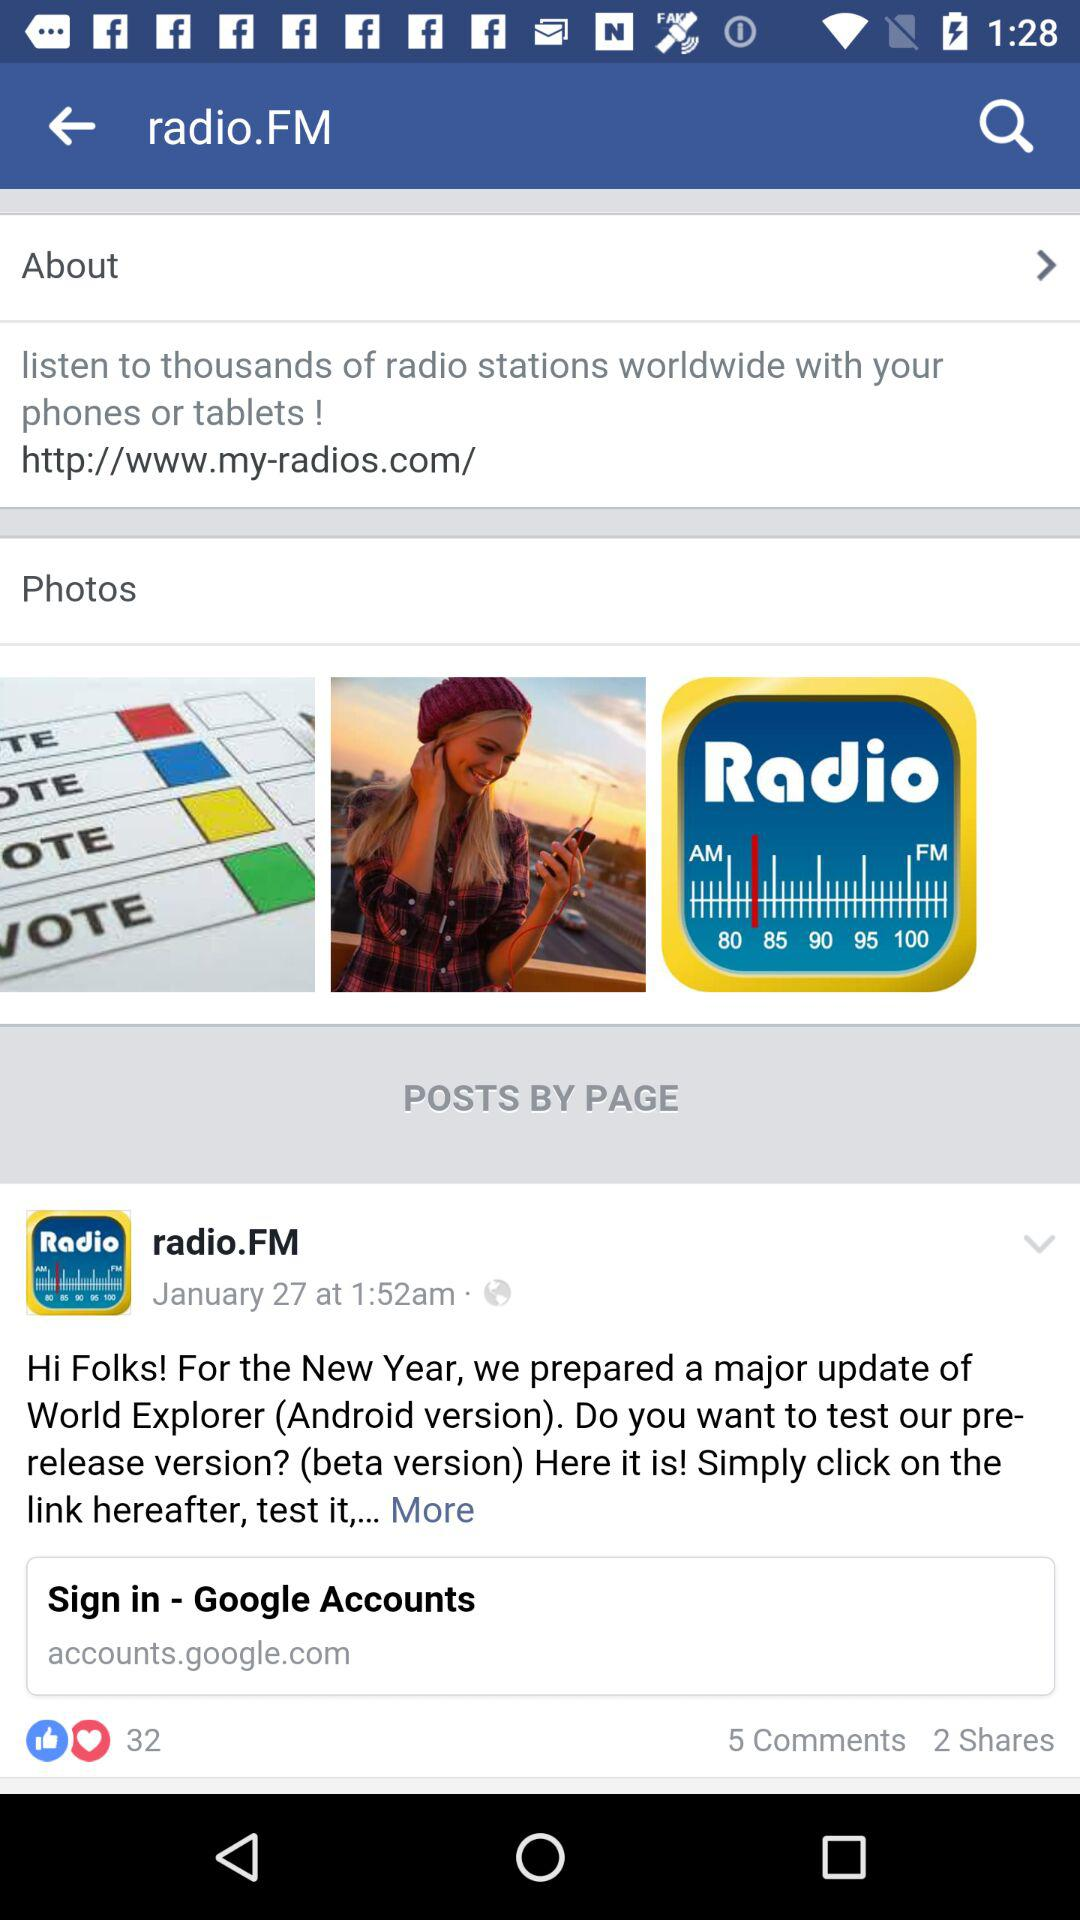How many comments are there? There are 5 comments. 